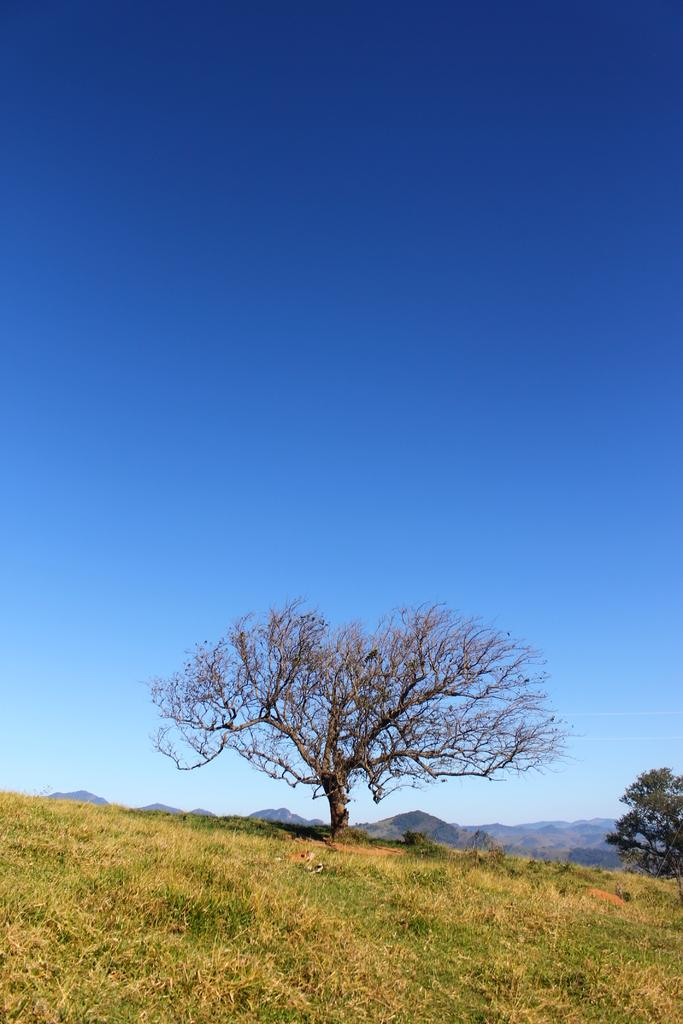What type of vegetation is present in the image? There are trees and grass in the image. What geographical feature can be seen in the background? There is a mountain in the image. What is the color of the sky in the image? The sky is pale blue in the image. Can you describe any animals present in the image? Yes, there is a bird sitting on a tree in the image. What type of print can be seen on the bird's toe in the image? There is no print or any indication of a bird's toe in the image. 